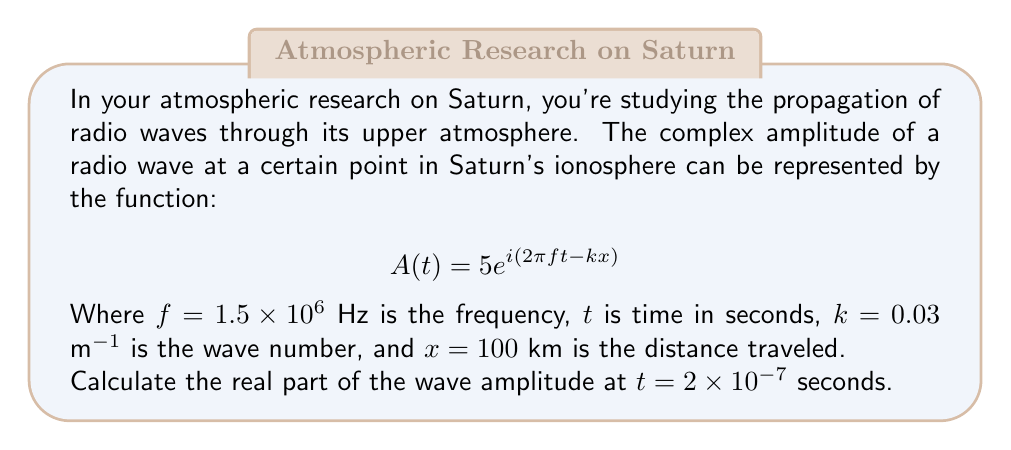Solve this math problem. Let's approach this step-by-step:

1) We're given the complex amplitude function:
   $$A(t) = 5e^{i(2\pi f t - kx)}$$

2) We need to substitute the given values:
   $f = 1.5 \times 10^6$ Hz
   $t = 2 \times 10^{-7}$ s
   $k = 0.03$ m⁻¹
   $x = 100$ km = $1 \times 10^5$ m

3) Let's calculate the exponent first:
   $$2\pi f t - kx = 2\pi(1.5 \times 10^6)(2 \times 10^{-7}) - 0.03(1 \times 10^5)$$
   $$= 1.885 - 3000 = -2998.115$$

4) Now our complex amplitude is:
   $$A(2 \times 10^{-7}) = 5e^{-2998.115i}$$

5) To find the real part, we use Euler's formula: $e^{ix} = \cos x + i \sin x$

6) The real part is thus:
   $$\text{Re}(A) = 5 \cos(-2998.115)$$

7) Using a calculator (as this is a practical application):
   $$5 \cos(-2998.115) \approx -1.946$$

The negative value indicates that at this instant, the wave amplitude is in the opposite direction of the positive reference.
Answer: $-1.946$ 